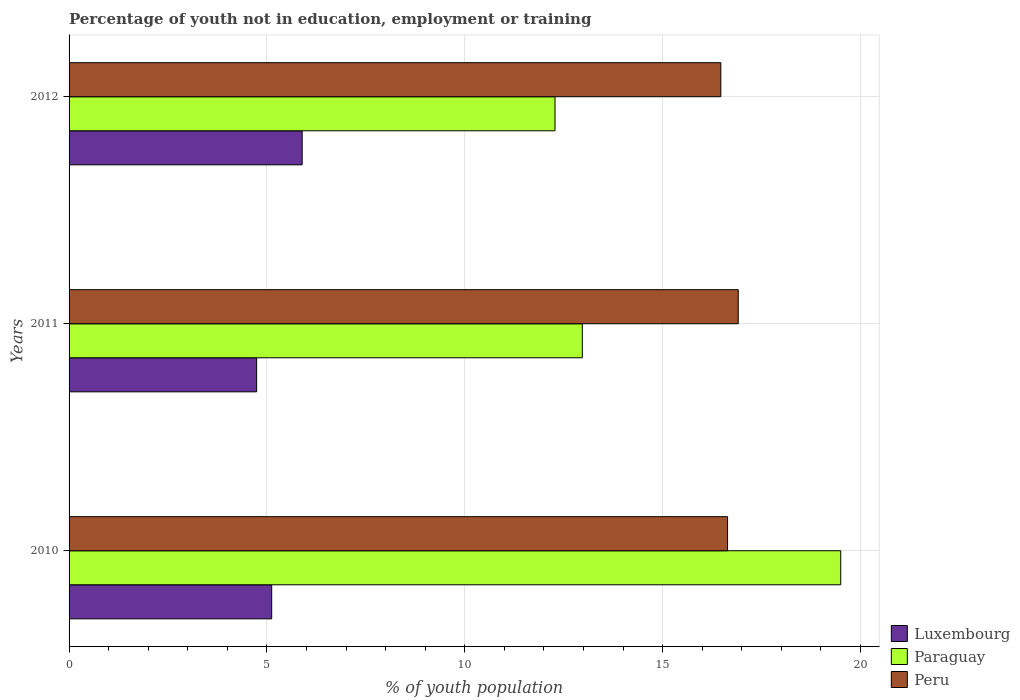How many different coloured bars are there?
Offer a very short reply. 3. How many bars are there on the 2nd tick from the top?
Make the answer very short. 3. How many bars are there on the 3rd tick from the bottom?
Make the answer very short. 3. In how many cases, is the number of bars for a given year not equal to the number of legend labels?
Your answer should be compact. 0. What is the percentage of unemployed youth population in in Peru in 2010?
Provide a succinct answer. 16.64. Across all years, what is the minimum percentage of unemployed youth population in in Paraguay?
Offer a very short reply. 12.28. What is the total percentage of unemployed youth population in in Peru in the graph?
Ensure brevity in your answer.  50.02. What is the difference between the percentage of unemployed youth population in in Luxembourg in 2010 and that in 2011?
Offer a very short reply. 0.38. What is the difference between the percentage of unemployed youth population in in Paraguay in 2011 and the percentage of unemployed youth population in in Luxembourg in 2012?
Offer a terse response. 7.08. What is the average percentage of unemployed youth population in in Peru per year?
Give a very brief answer. 16.67. In the year 2011, what is the difference between the percentage of unemployed youth population in in Luxembourg and percentage of unemployed youth population in in Peru?
Your response must be concise. -12.17. In how many years, is the percentage of unemployed youth population in in Luxembourg greater than 1 %?
Your answer should be very brief. 3. What is the ratio of the percentage of unemployed youth population in in Paraguay in 2010 to that in 2012?
Your answer should be very brief. 1.59. Is the difference between the percentage of unemployed youth population in in Luxembourg in 2010 and 2011 greater than the difference between the percentage of unemployed youth population in in Peru in 2010 and 2011?
Offer a terse response. Yes. What is the difference between the highest and the second highest percentage of unemployed youth population in in Paraguay?
Make the answer very short. 6.53. What is the difference between the highest and the lowest percentage of unemployed youth population in in Luxembourg?
Give a very brief answer. 1.15. In how many years, is the percentage of unemployed youth population in in Peru greater than the average percentage of unemployed youth population in in Peru taken over all years?
Provide a short and direct response. 1. Is the sum of the percentage of unemployed youth population in in Luxembourg in 2010 and 2012 greater than the maximum percentage of unemployed youth population in in Paraguay across all years?
Give a very brief answer. No. What does the 1st bar from the top in 2012 represents?
Ensure brevity in your answer.  Peru. What does the 3rd bar from the bottom in 2011 represents?
Offer a very short reply. Peru. Is it the case that in every year, the sum of the percentage of unemployed youth population in in Peru and percentage of unemployed youth population in in Paraguay is greater than the percentage of unemployed youth population in in Luxembourg?
Give a very brief answer. Yes. Does the graph contain grids?
Provide a succinct answer. Yes. Where does the legend appear in the graph?
Keep it short and to the point. Bottom right. How many legend labels are there?
Your response must be concise. 3. How are the legend labels stacked?
Offer a very short reply. Vertical. What is the title of the graph?
Give a very brief answer. Percentage of youth not in education, employment or training. Does "Bosnia and Herzegovina" appear as one of the legend labels in the graph?
Offer a very short reply. No. What is the label or title of the X-axis?
Your answer should be very brief. % of youth population. What is the % of youth population of Luxembourg in 2010?
Your response must be concise. 5.12. What is the % of youth population in Paraguay in 2010?
Offer a terse response. 19.5. What is the % of youth population in Peru in 2010?
Keep it short and to the point. 16.64. What is the % of youth population in Luxembourg in 2011?
Your response must be concise. 4.74. What is the % of youth population of Paraguay in 2011?
Your answer should be compact. 12.97. What is the % of youth population of Peru in 2011?
Give a very brief answer. 16.91. What is the % of youth population of Luxembourg in 2012?
Your response must be concise. 5.89. What is the % of youth population in Paraguay in 2012?
Your response must be concise. 12.28. What is the % of youth population of Peru in 2012?
Provide a succinct answer. 16.47. Across all years, what is the maximum % of youth population in Luxembourg?
Offer a terse response. 5.89. Across all years, what is the maximum % of youth population of Paraguay?
Your answer should be very brief. 19.5. Across all years, what is the maximum % of youth population of Peru?
Ensure brevity in your answer.  16.91. Across all years, what is the minimum % of youth population of Luxembourg?
Your response must be concise. 4.74. Across all years, what is the minimum % of youth population in Paraguay?
Provide a succinct answer. 12.28. Across all years, what is the minimum % of youth population of Peru?
Offer a very short reply. 16.47. What is the total % of youth population of Luxembourg in the graph?
Offer a very short reply. 15.75. What is the total % of youth population in Paraguay in the graph?
Give a very brief answer. 44.75. What is the total % of youth population of Peru in the graph?
Offer a very short reply. 50.02. What is the difference between the % of youth population of Luxembourg in 2010 and that in 2011?
Offer a terse response. 0.38. What is the difference between the % of youth population in Paraguay in 2010 and that in 2011?
Offer a very short reply. 6.53. What is the difference between the % of youth population of Peru in 2010 and that in 2011?
Provide a succinct answer. -0.27. What is the difference between the % of youth population in Luxembourg in 2010 and that in 2012?
Make the answer very short. -0.77. What is the difference between the % of youth population in Paraguay in 2010 and that in 2012?
Make the answer very short. 7.22. What is the difference between the % of youth population of Peru in 2010 and that in 2012?
Keep it short and to the point. 0.17. What is the difference between the % of youth population of Luxembourg in 2011 and that in 2012?
Offer a very short reply. -1.15. What is the difference between the % of youth population of Paraguay in 2011 and that in 2012?
Offer a terse response. 0.69. What is the difference between the % of youth population of Peru in 2011 and that in 2012?
Ensure brevity in your answer.  0.44. What is the difference between the % of youth population in Luxembourg in 2010 and the % of youth population in Paraguay in 2011?
Ensure brevity in your answer.  -7.85. What is the difference between the % of youth population in Luxembourg in 2010 and the % of youth population in Peru in 2011?
Your answer should be compact. -11.79. What is the difference between the % of youth population in Paraguay in 2010 and the % of youth population in Peru in 2011?
Offer a terse response. 2.59. What is the difference between the % of youth population in Luxembourg in 2010 and the % of youth population in Paraguay in 2012?
Your answer should be compact. -7.16. What is the difference between the % of youth population of Luxembourg in 2010 and the % of youth population of Peru in 2012?
Provide a succinct answer. -11.35. What is the difference between the % of youth population of Paraguay in 2010 and the % of youth population of Peru in 2012?
Your answer should be very brief. 3.03. What is the difference between the % of youth population of Luxembourg in 2011 and the % of youth population of Paraguay in 2012?
Your answer should be compact. -7.54. What is the difference between the % of youth population in Luxembourg in 2011 and the % of youth population in Peru in 2012?
Your answer should be very brief. -11.73. What is the average % of youth population in Luxembourg per year?
Your response must be concise. 5.25. What is the average % of youth population of Paraguay per year?
Ensure brevity in your answer.  14.92. What is the average % of youth population of Peru per year?
Provide a short and direct response. 16.67. In the year 2010, what is the difference between the % of youth population of Luxembourg and % of youth population of Paraguay?
Provide a succinct answer. -14.38. In the year 2010, what is the difference between the % of youth population of Luxembourg and % of youth population of Peru?
Ensure brevity in your answer.  -11.52. In the year 2010, what is the difference between the % of youth population in Paraguay and % of youth population in Peru?
Provide a succinct answer. 2.86. In the year 2011, what is the difference between the % of youth population in Luxembourg and % of youth population in Paraguay?
Your response must be concise. -8.23. In the year 2011, what is the difference between the % of youth population in Luxembourg and % of youth population in Peru?
Your response must be concise. -12.17. In the year 2011, what is the difference between the % of youth population of Paraguay and % of youth population of Peru?
Give a very brief answer. -3.94. In the year 2012, what is the difference between the % of youth population in Luxembourg and % of youth population in Paraguay?
Ensure brevity in your answer.  -6.39. In the year 2012, what is the difference between the % of youth population in Luxembourg and % of youth population in Peru?
Provide a succinct answer. -10.58. In the year 2012, what is the difference between the % of youth population in Paraguay and % of youth population in Peru?
Offer a very short reply. -4.19. What is the ratio of the % of youth population of Luxembourg in 2010 to that in 2011?
Make the answer very short. 1.08. What is the ratio of the % of youth population of Paraguay in 2010 to that in 2011?
Offer a terse response. 1.5. What is the ratio of the % of youth population in Peru in 2010 to that in 2011?
Provide a succinct answer. 0.98. What is the ratio of the % of youth population in Luxembourg in 2010 to that in 2012?
Offer a terse response. 0.87. What is the ratio of the % of youth population of Paraguay in 2010 to that in 2012?
Offer a terse response. 1.59. What is the ratio of the % of youth population in Peru in 2010 to that in 2012?
Your response must be concise. 1.01. What is the ratio of the % of youth population in Luxembourg in 2011 to that in 2012?
Give a very brief answer. 0.8. What is the ratio of the % of youth population of Paraguay in 2011 to that in 2012?
Your answer should be very brief. 1.06. What is the ratio of the % of youth population in Peru in 2011 to that in 2012?
Your response must be concise. 1.03. What is the difference between the highest and the second highest % of youth population of Luxembourg?
Keep it short and to the point. 0.77. What is the difference between the highest and the second highest % of youth population of Paraguay?
Your response must be concise. 6.53. What is the difference between the highest and the second highest % of youth population of Peru?
Keep it short and to the point. 0.27. What is the difference between the highest and the lowest % of youth population of Luxembourg?
Ensure brevity in your answer.  1.15. What is the difference between the highest and the lowest % of youth population in Paraguay?
Offer a terse response. 7.22. What is the difference between the highest and the lowest % of youth population in Peru?
Ensure brevity in your answer.  0.44. 